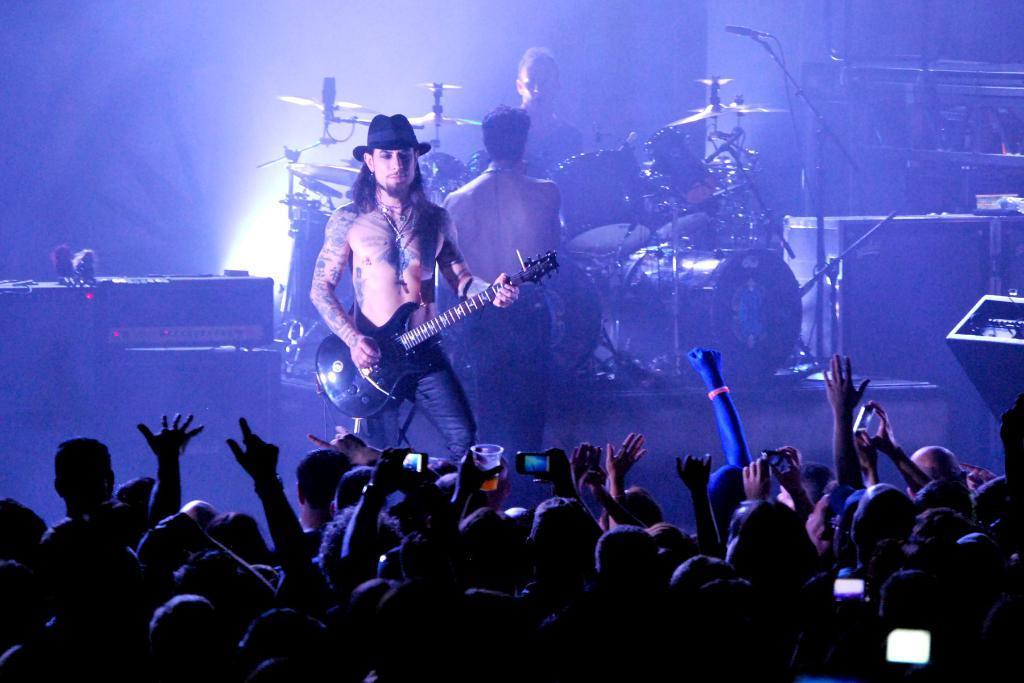Describe this image in one or two sentences. There are three musicians in this image performing at the stage in front of the crowd. Man in the center is wearing a black colour hat and holding a guitar in his hand and is looking at the crowd. In the background man is standing and speaking to this man in the sitting in front of the drums. At the left side there is speakers and light. At the right side there is a mic and stand. 